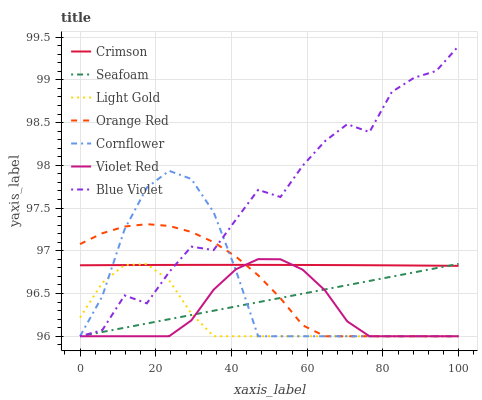Does Light Gold have the minimum area under the curve?
Answer yes or no. Yes. Does Blue Violet have the maximum area under the curve?
Answer yes or no. Yes. Does Violet Red have the minimum area under the curve?
Answer yes or no. No. Does Violet Red have the maximum area under the curve?
Answer yes or no. No. Is Seafoam the smoothest?
Answer yes or no. Yes. Is Blue Violet the roughest?
Answer yes or no. Yes. Is Violet Red the smoothest?
Answer yes or no. No. Is Violet Red the roughest?
Answer yes or no. No. Does Cornflower have the lowest value?
Answer yes or no. Yes. Does Crimson have the lowest value?
Answer yes or no. No. Does Blue Violet have the highest value?
Answer yes or no. Yes. Does Violet Red have the highest value?
Answer yes or no. No. Does Violet Red intersect Orange Red?
Answer yes or no. Yes. Is Violet Red less than Orange Red?
Answer yes or no. No. Is Violet Red greater than Orange Red?
Answer yes or no. No. 